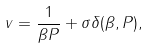<formula> <loc_0><loc_0><loc_500><loc_500>v = \frac { 1 } { \beta P } + \sigma \delta ( \beta , P ) ,</formula> 